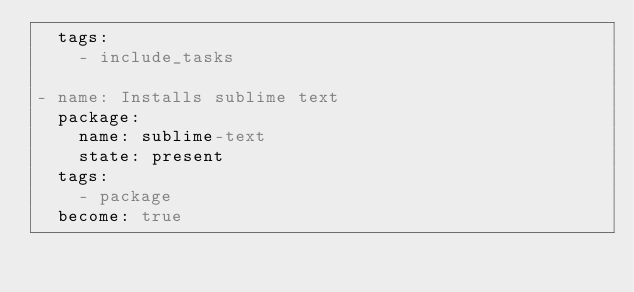Convert code to text. <code><loc_0><loc_0><loc_500><loc_500><_YAML_>  tags:
    - include_tasks

- name: Installs sublime text
  package:
    name: sublime-text
    state: present
  tags:
    - package
  become: true
</code> 